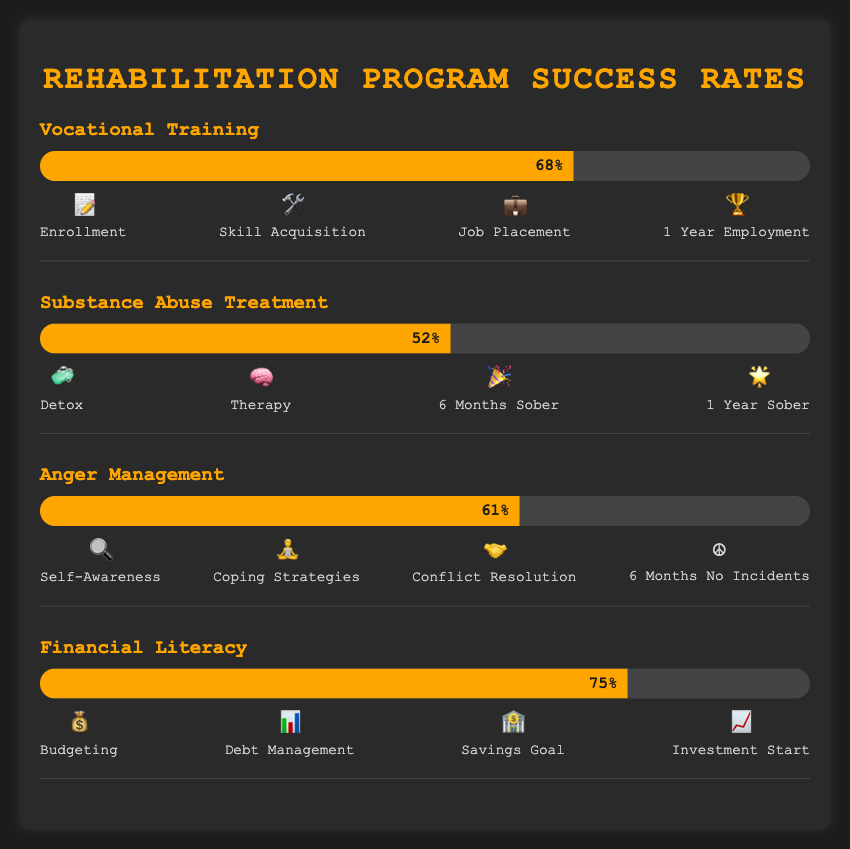Which rehabilitation program has the highest success rate? The "Financial Literacy" program shows the highest success rate at 75%. Among the bars visualized, this one stretches the furthest to the right, indicating it has the highest percentage value.
Answer: Financial Literacy What is the success rate of Substance Abuse Treatment? The "Substance Abuse Treatment" program is shown with a success rate of 52%, directly labeled on its progress bar.
Answer: 52% Which milestone in the Financial Literacy program is associated with the emoji 💰? The first milestone "Budgeting" in the Financial Literacy program is paired with the emoji 💰. This is the initial stage in the sequence of emojis presented for the program.
Answer: Budgeting Compare the success rates of Vocational Training and Anger Management. Which program has a higher success rate? The Vocational Training program has a success rate of 68%, whereas the Anger Management program has a success rate of 61%. By comparing these values directly, Vocational Training has a higher success rate.
Answer: Vocational Training What are the milestones for the Anger Management program? There are four milestones in the Anger Management program: 🔍 Self-Awareness, 🧘 Coping Strategies, 🤝 Conflict Resolution, and ☮️ 6 Months No Incidents. Each milestone is paired with a specific emoji as shown in the figure.
Answer: 🔍 Self-Awareness, 🧘 Coping Strategies, 🤝 Conflict Resolution, ☮️ 6 Months No Incidents How much greater is the success rate of Financial Literacy compared to Substance Abuse Treatment? The success rate of Financial Literacy is 75%, whereas the Substance Abuse Treatment is 52%. The difference in their success rates is calculated as 75% - 52% = 23%.
Answer: 23% List all the stages represented by emoji in the Vocational Training program. The Vocational Training program stages, as represented by emojis, are: 📝 Enrollment, 🛠️ Skill Acquisition, 💼 Job Placement, and 🏆 1 Year Employment. These are the four milestones sequentially illustrated in the chart.
Answer: 📝 Enrollment, 🛠️ Skill Acquisition, 💼 Job Placement, 🏆 1 Year Employment Does the Anger Management program have a higher success rate than Substance Abuse Treatment? The Anger Management program has a success rate of 61% while the Substance Abuse Treatment program has a success rate of 52%. Since 61% is greater than 52%, the Anger Management program has a higher success rate.
Answer: Yes Which program has the lowest success rate? The Substance Abuse Treatment program has the lowest success rate at 52%. This is the smallest percentage value among the given programs in the figure.
Answer: Substance Abuse Treatment 